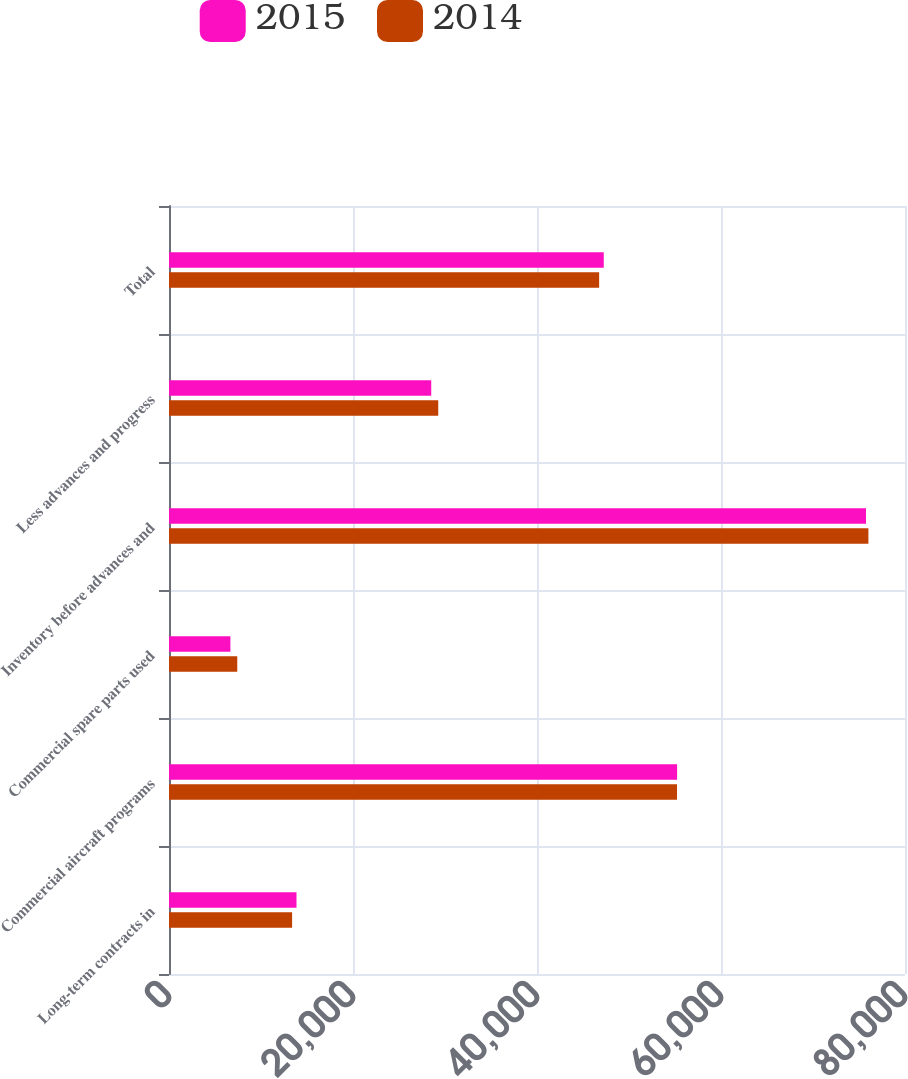Convert chart to OTSL. <chart><loc_0><loc_0><loc_500><loc_500><stacked_bar_chart><ecel><fcel>Long-term contracts in<fcel>Commercial aircraft programs<fcel>Commercial spare parts used<fcel>Inventory before advances and<fcel>Less advances and progress<fcel>Total<nl><fcel>2015<fcel>13858<fcel>55230<fcel>6673<fcel>75761<fcel>28504<fcel>47257<nl><fcel>2014<fcel>13381<fcel>55220<fcel>7421<fcel>76022<fcel>29266<fcel>46756<nl></chart> 